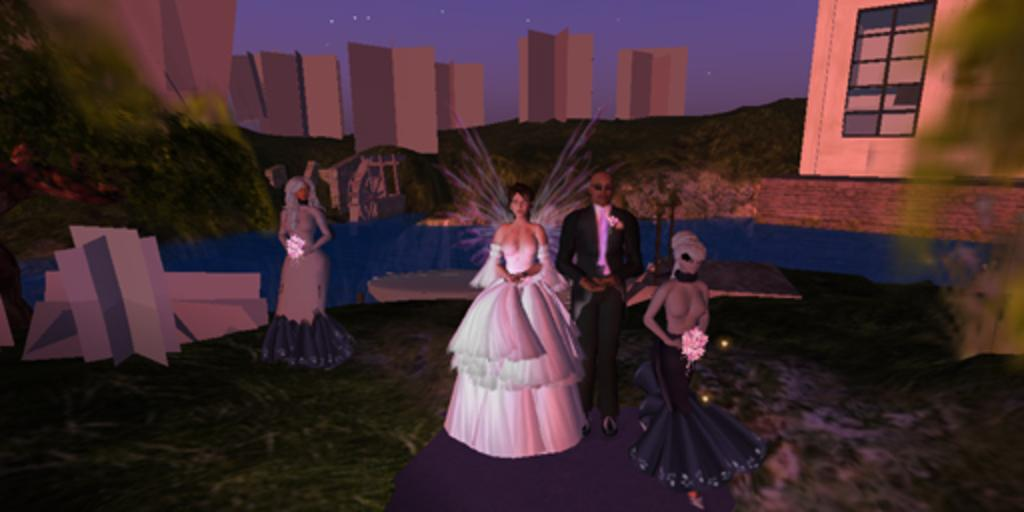How many people are in the image? There are persons in the image, but the exact number is not specified. What are the persons doing in the image? The persons are standing in the image. What objects are the persons holding in the image? The persons are holding flower vases in the image. What type of bone can be seen in the image? There is no bone present in the image. How many pizzas are visible in the image? There is no mention of pizzas in the image. What type of leather is used to make the shoes worn by the persons in the image? There is no information about shoes or leather in the image. 